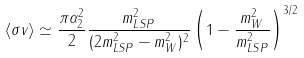Convert formula to latex. <formula><loc_0><loc_0><loc_500><loc_500>\langle \sigma v \rangle \simeq \frac { \pi \alpha _ { 2 } ^ { 2 } } { 2 } \frac { m _ { L S P } ^ { 2 } } { ( 2 m _ { L S P } ^ { 2 } - m _ { W } ^ { 2 } ) ^ { 2 } } \left ( 1 - \frac { m _ { W } ^ { 2 } } { m _ { L S P } ^ { 2 } } \right ) ^ { 3 / 2 }</formula> 